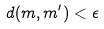<formula> <loc_0><loc_0><loc_500><loc_500>d ( m , m ^ { \prime } ) < \epsilon</formula> 